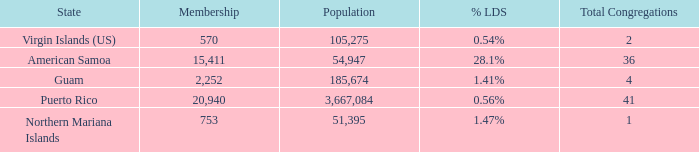What is the highest Population, when State is Puerto Rico, and when Total Congregations is greater than 41? None. 